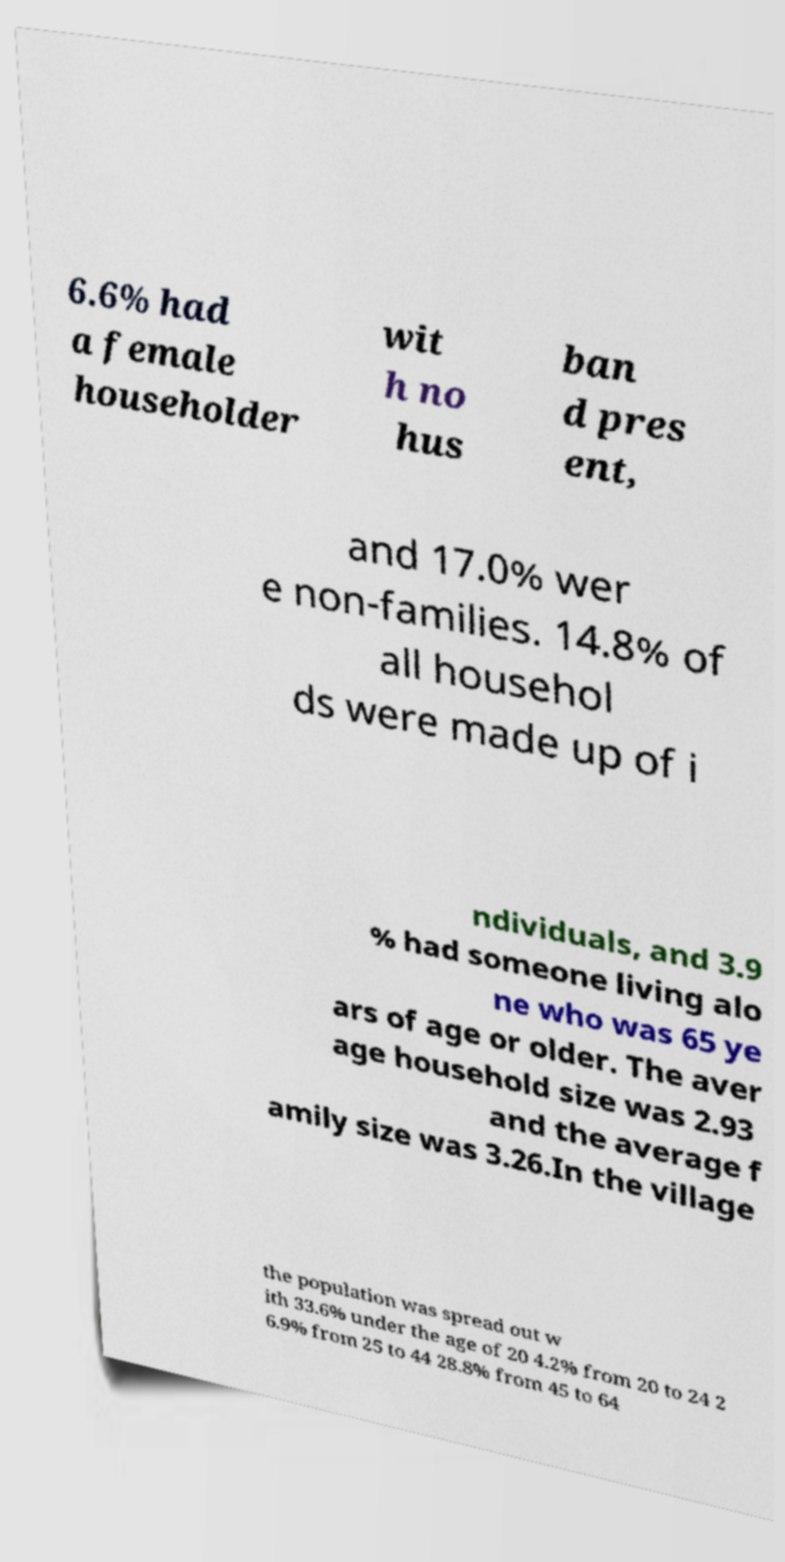There's text embedded in this image that I need extracted. Can you transcribe it verbatim? 6.6% had a female householder wit h no hus ban d pres ent, and 17.0% wer e non-families. 14.8% of all househol ds were made up of i ndividuals, and 3.9 % had someone living alo ne who was 65 ye ars of age or older. The aver age household size was 2.93 and the average f amily size was 3.26.In the village the population was spread out w ith 33.6% under the age of 20 4.2% from 20 to 24 2 6.9% from 25 to 44 28.8% from 45 to 64 